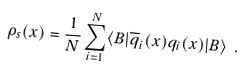Convert formula to latex. <formula><loc_0><loc_0><loc_500><loc_500>\rho _ { s } ( x ) = \frac { 1 } { N } \sum _ { i = 1 } ^ { N } \langle B | \overline { q } _ { i } ( x ) q _ { i } ( x ) | B \rangle \ .</formula> 